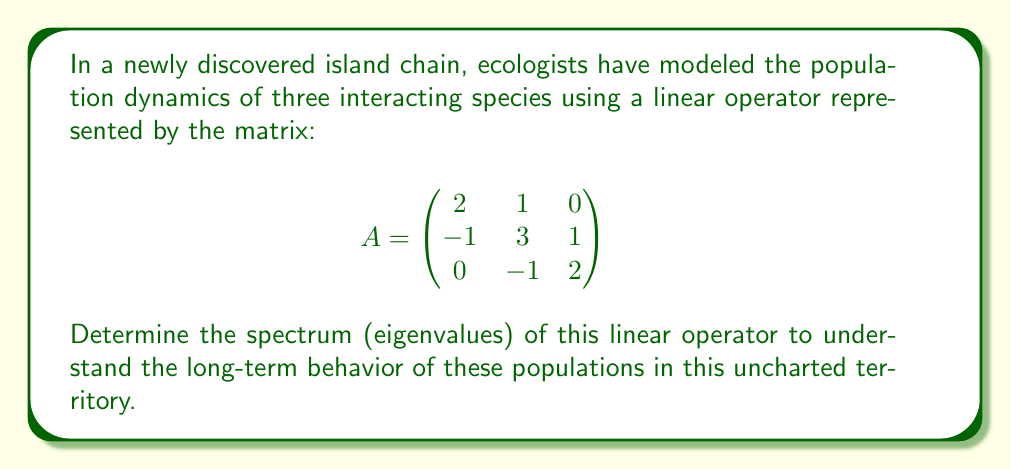Teach me how to tackle this problem. To find the spectrum of the linear operator A, we need to determine its eigenvalues. This involves the following steps:

1) Calculate the characteristic polynomial:
   $$det(A - \lambda I) = 0$$
   where $I$ is the 3x3 identity matrix and $\lambda$ represents the eigenvalues.

2) Expand the determinant:
   $$\begin{vmatrix}
   2-\lambda & 1 & 0 \\
   -1 & 3-\lambda & 1 \\
   0 & -1 & 2-\lambda
   \end{vmatrix} = 0$$

3) Calculate the determinant:
   $$(2-\lambda)[(3-\lambda)(2-\lambda) - 1] + 1[-(2-\lambda)] = 0$$
   $$(2-\lambda)[(6-5\lambda+\lambda^2) - 1] - (2-\lambda) = 0$$
   $$(2-\lambda)(5-5\lambda+\lambda^2) - (2-\lambda) = 0$$
   $$10-10\lambda+2\lambda^2-5\lambda+5\lambda^2-\lambda^3-2+\lambda = 0$$
   $$-\lambda^3+7\lambda^2-14\lambda+8 = 0$$

4) Factor the cubic equation:
   $$-(\lambda-1)(\lambda-3)(\lambda-4) = 0$$

5) Solve for $\lambda$:
   $$\lambda = 1, 3, \text{ or } 4$$

These eigenvalues form the spectrum of the linear operator A.
Answer: $\{1, 3, 4\}$ 